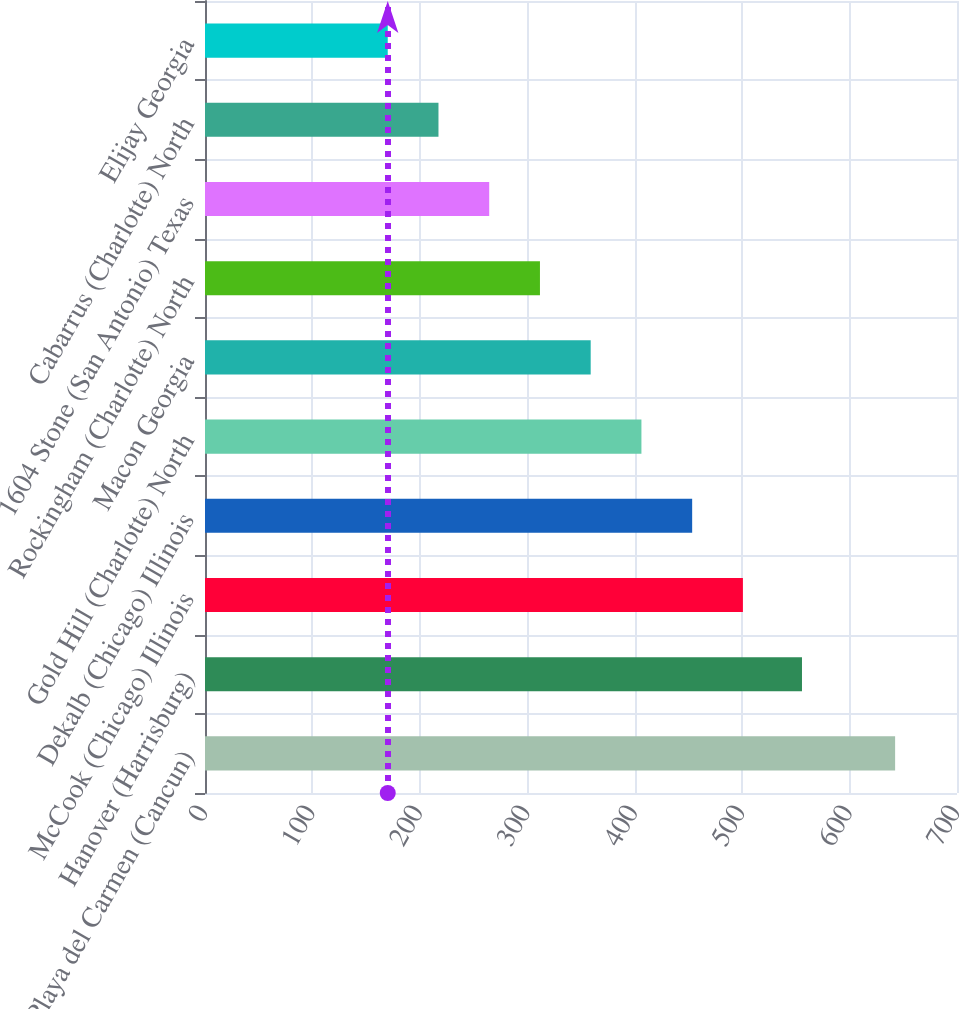Convert chart to OTSL. <chart><loc_0><loc_0><loc_500><loc_500><bar_chart><fcel>Playa del Carmen (Cancun)<fcel>Hanover (Harrisburg)<fcel>McCook (Chicago) Illinois<fcel>Dekalb (Chicago) Illinois<fcel>Gold Hill (Charlotte) North<fcel>Macon Georgia<fcel>Rockingham (Charlotte) North<fcel>1604 Stone (San Antonio) Texas<fcel>Cabarrus (Charlotte) North<fcel>Elijay Georgia<nl><fcel>642.4<fcel>555.7<fcel>500.71<fcel>453.48<fcel>406.25<fcel>359.02<fcel>311.79<fcel>264.56<fcel>217.33<fcel>170.1<nl></chart> 